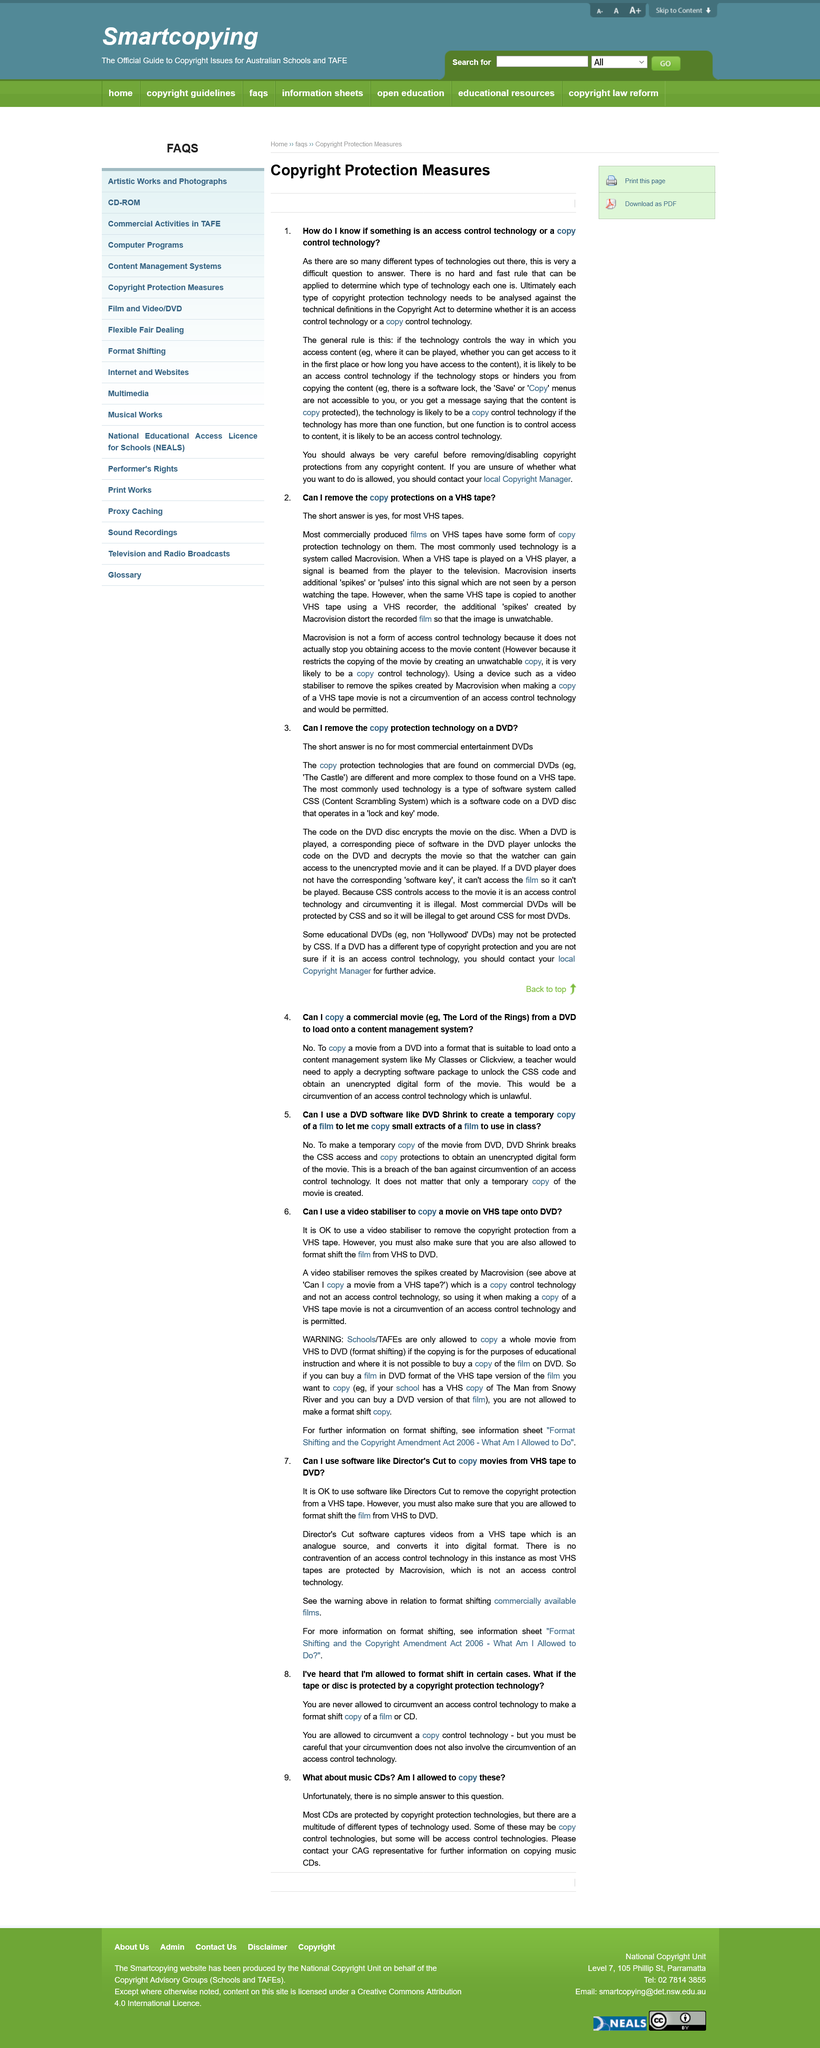Highlight a few significant elements in this photo. Each type of copyright protection should be analyzed against the technical definitions of the Copyright Act. Macrovision technology is a digital rights management (DRM) technique that prevents unauthorized copying and reproduction of digital media by creating an unwatchable copy of the original content. The general rule to determine if access control technology exists is that if the technology controls the way in which the content can be accessed, then it can be considered access control technology. Some educational DVDs do not use the Content Scramble System (CSS) to protect their content. Commercially produced films are typically recorded on VHS tapes. 